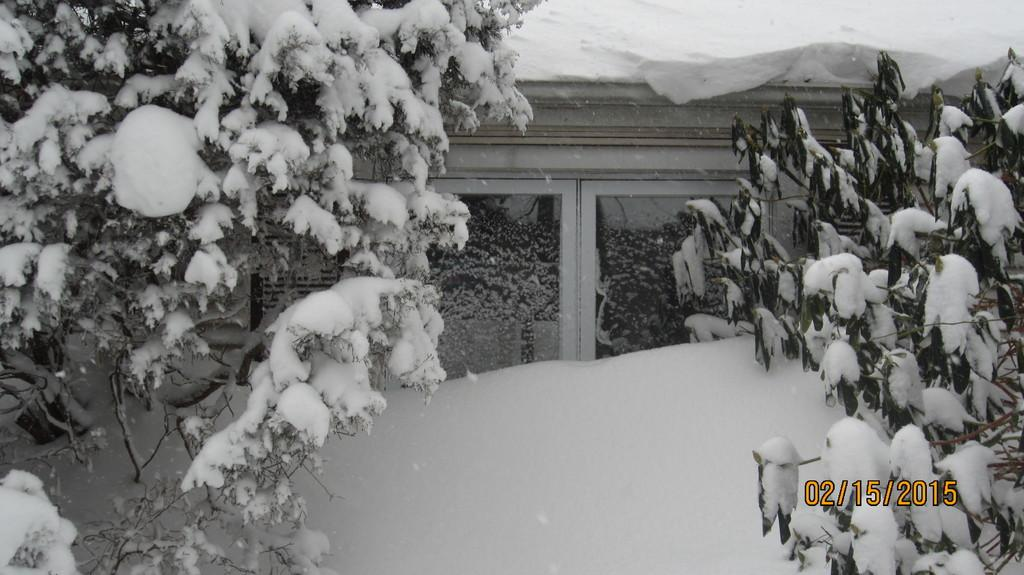What is the predominant color of the snow in the image? The snow in the image is white. What type of natural elements can be seen in the image? There are trees in the image. What type of structure is visible in the image? There is a house in the image. Can you describe any additional features of the image? There is a watermark in the image. Are there any cacti visible in the image? No, there are no cacti present in the image. The image features snow, trees, a house, and a watermark, which are not typically associated with cacti. 